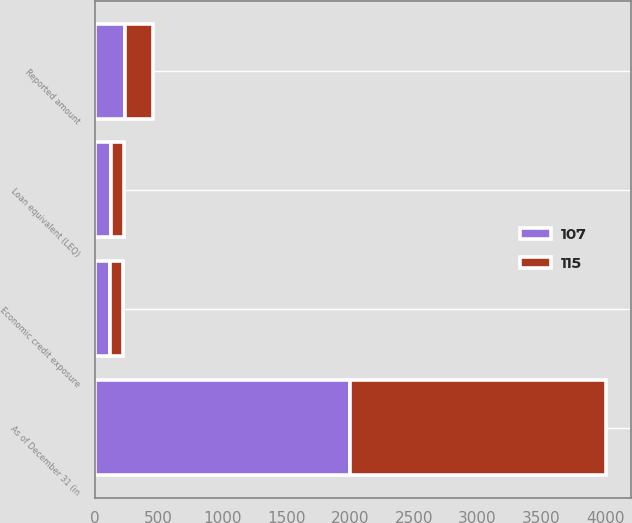Convert chart to OTSL. <chart><loc_0><loc_0><loc_500><loc_500><stacked_bar_chart><ecel><fcel>As of December 31 (in<fcel>Reported amount<fcel>Loan equivalent (LEQ)<fcel>Economic credit exposure<nl><fcel>115<fcel>2003<fcel>216<fcel>109<fcel>107<nl><fcel>107<fcel>2002<fcel>238<fcel>123<fcel>115<nl></chart> 